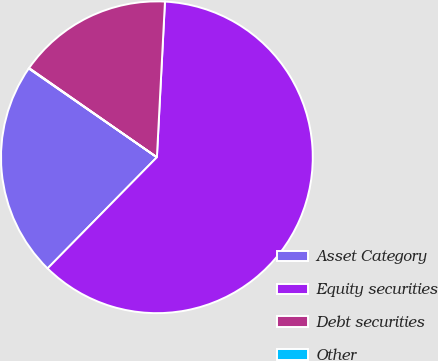Convert chart to OTSL. <chart><loc_0><loc_0><loc_500><loc_500><pie_chart><fcel>Asset Category<fcel>Equity securities<fcel>Debt securities<fcel>Other<nl><fcel>22.28%<fcel>61.55%<fcel>16.13%<fcel>0.05%<nl></chart> 